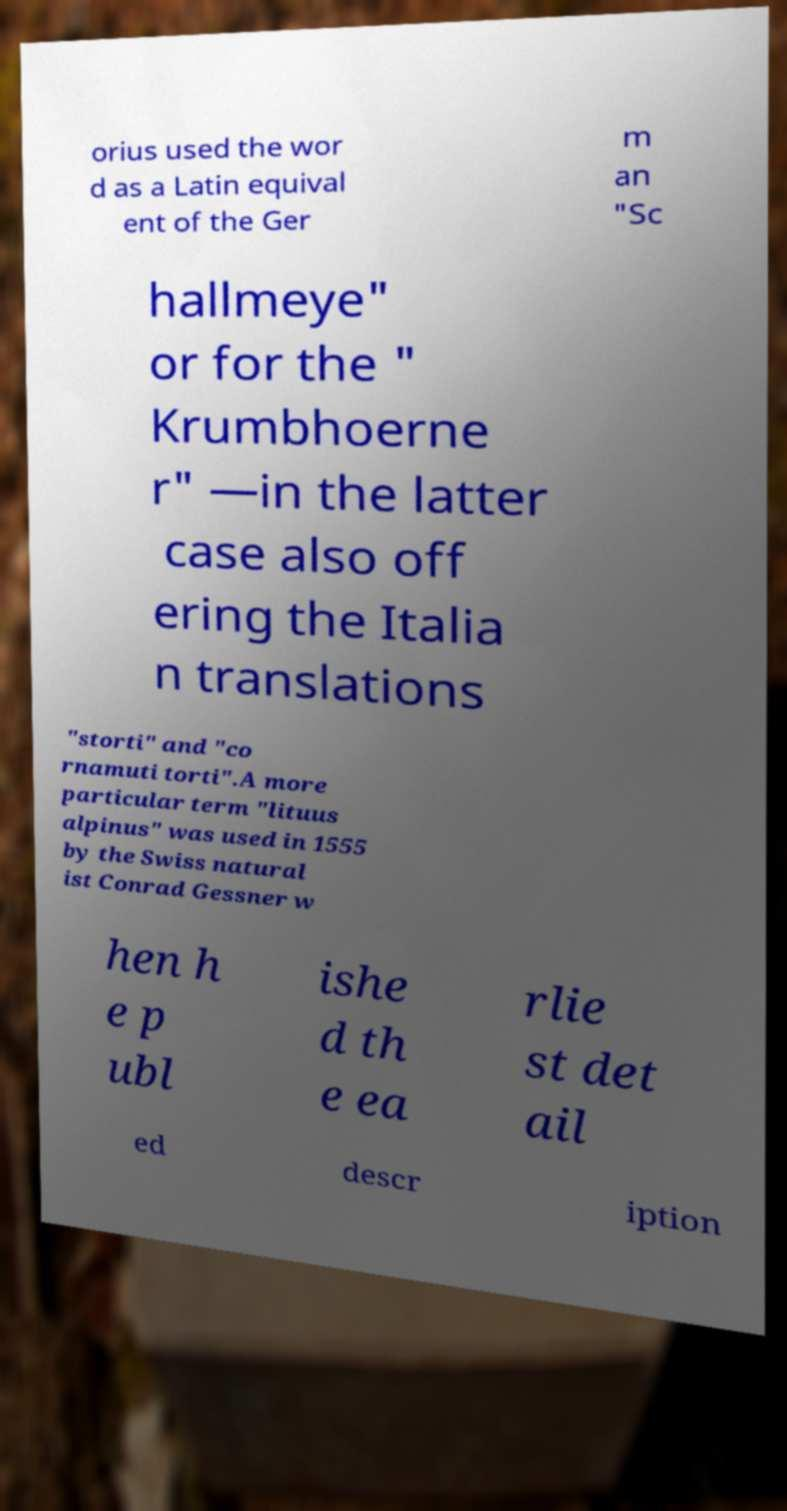Please identify and transcribe the text found in this image. orius used the wor d as a Latin equival ent of the Ger m an "Sc hallmeye" or for the " Krumbhoerne r" —in the latter case also off ering the Italia n translations "storti" and "co rnamuti torti".A more particular term "lituus alpinus" was used in 1555 by the Swiss natural ist Conrad Gessner w hen h e p ubl ishe d th e ea rlie st det ail ed descr iption 